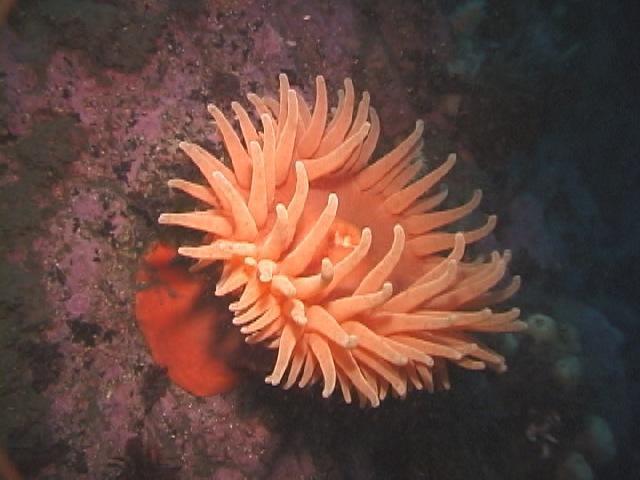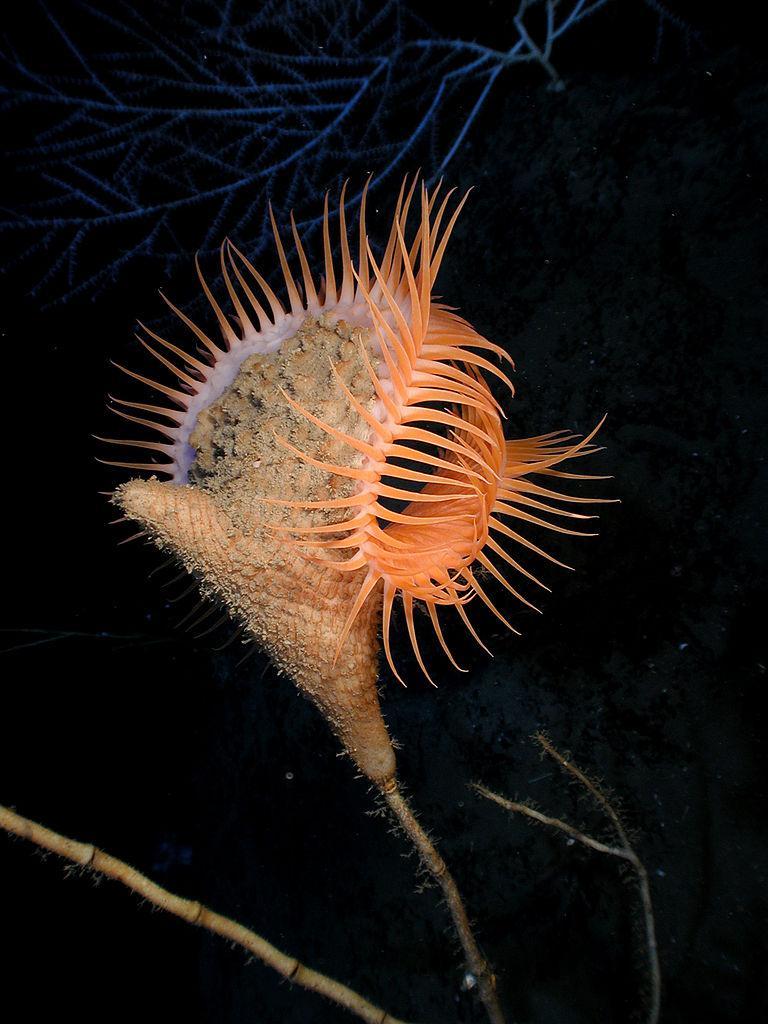The first image is the image on the left, the second image is the image on the right. Considering the images on both sides, is "There are exactly one sea anemone in each of the images." valid? Answer yes or no. Yes. The first image is the image on the left, the second image is the image on the right. Assess this claim about the two images: "One image features a peach-colored anemone with a thick stalk, and the other shows anemone with a black-and-white zebra-look pattern on the stalk.". Correct or not? Answer yes or no. No. 